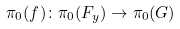Convert formula to latex. <formula><loc_0><loc_0><loc_500><loc_500>\pi _ { 0 } ( f ) \colon \pi _ { 0 } ( F _ { y } ) \to \pi _ { 0 } ( G )</formula> 